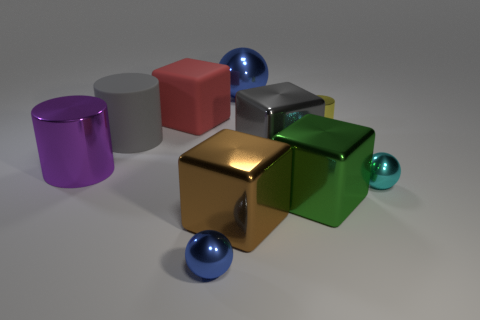How many cyan metallic objects are the same shape as the small blue metal object?
Keep it short and to the point. 1. There is a big green thing that is the same shape as the gray metallic object; what is it made of?
Keep it short and to the point. Metal. There is a blue shiny sphere that is to the right of the blue thing in front of the big blue sphere; is there a purple cylinder that is right of it?
Your answer should be compact. No. What number of other things are there of the same color as the small metallic cylinder?
Provide a succinct answer. 0. How many large metal things are both in front of the yellow cylinder and on the right side of the large red rubber thing?
Provide a succinct answer. 3. There is a big brown thing; what shape is it?
Your answer should be very brief. Cube. What number of other objects are the same material as the brown block?
Your answer should be compact. 7. There is a cylinder to the right of the tiny metal ball that is to the left of the metal ball right of the big ball; what color is it?
Offer a terse response. Yellow. There is a brown cube that is the same size as the purple object; what is it made of?
Your answer should be compact. Metal. What number of objects are either tiny things behind the tiny cyan metallic object or blue matte spheres?
Offer a terse response. 1. 